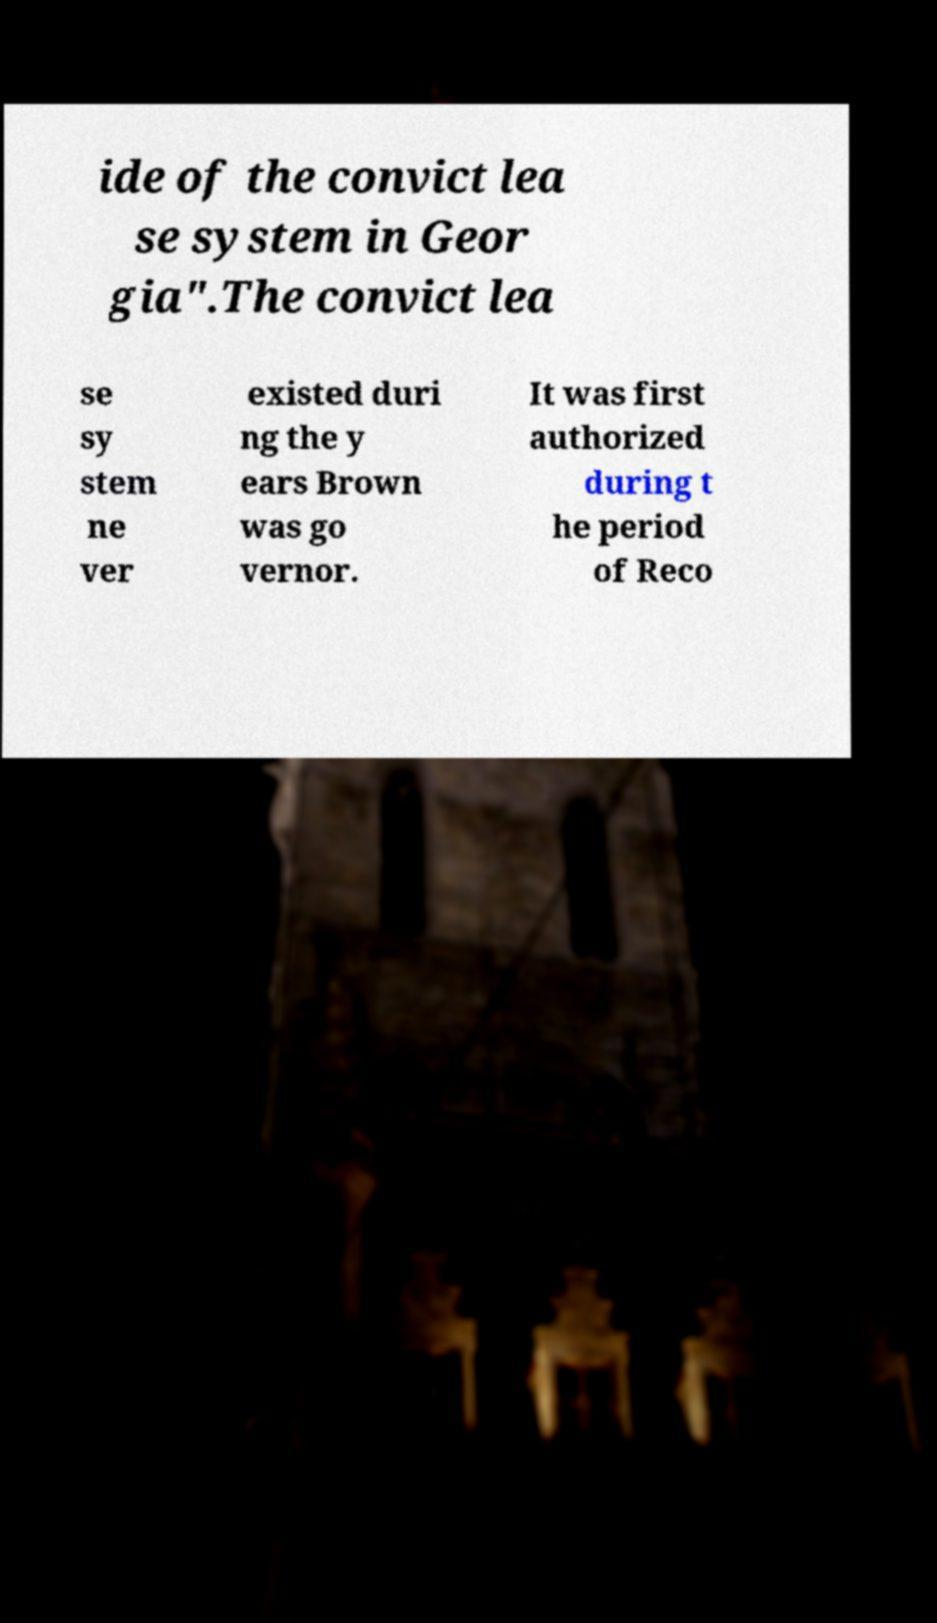For documentation purposes, I need the text within this image transcribed. Could you provide that? ide of the convict lea se system in Geor gia".The convict lea se sy stem ne ver existed duri ng the y ears Brown was go vernor. It was first authorized during t he period of Reco 